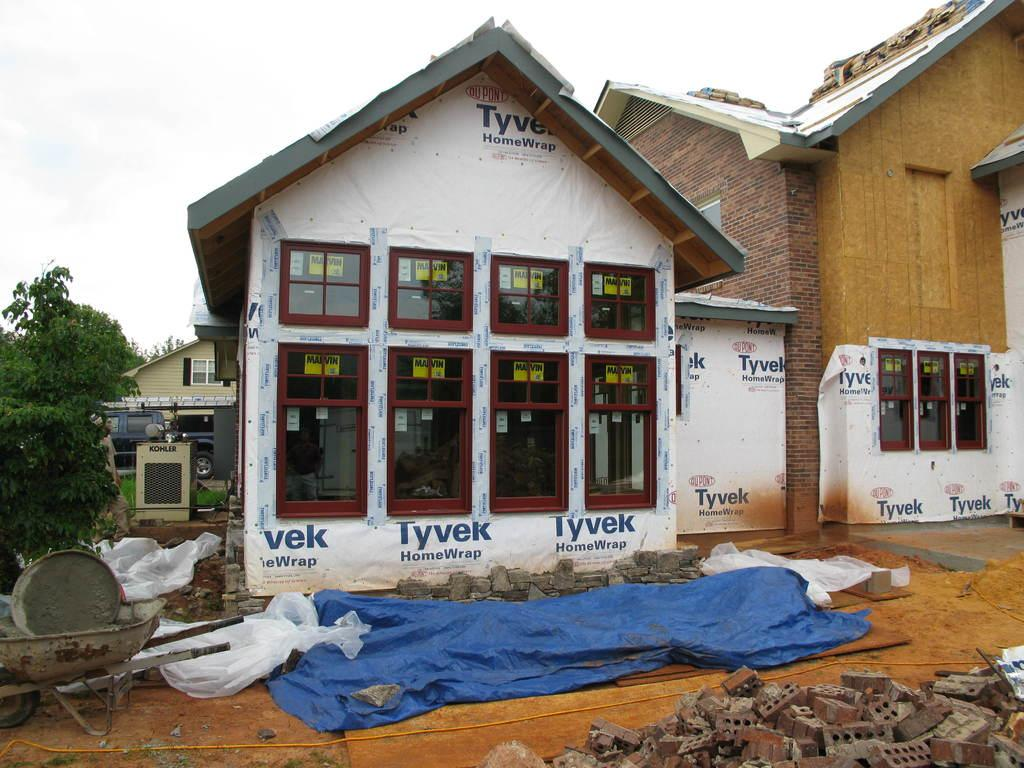What type of structures are visible in the image? There are houses in the image. Can you describe any additional details about the houses? There is construction material in front of one of the houses, and there is a tree beside one of the houses. What color is the crayon used to draw on the tree in the image? There is no crayon or drawing on the tree in the image. Can you tell me how many cubs are playing in front of the house with the tree? There are no cubs present in the image. 